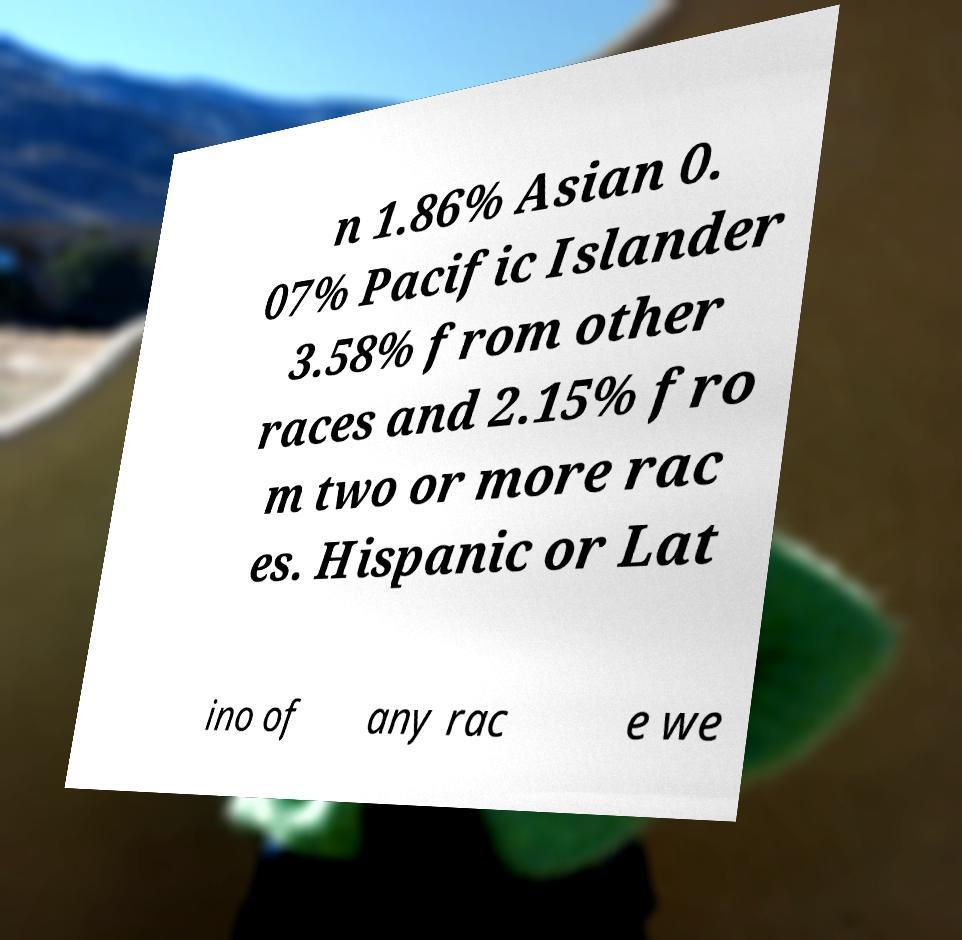Could you assist in decoding the text presented in this image and type it out clearly? n 1.86% Asian 0. 07% Pacific Islander 3.58% from other races and 2.15% fro m two or more rac es. Hispanic or Lat ino of any rac e we 